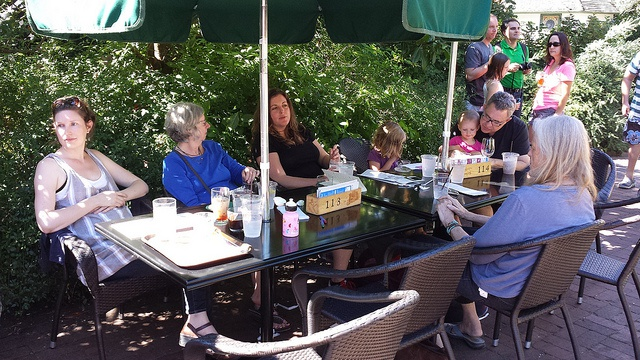Describe the objects in this image and their specific colors. I can see umbrella in darkgreen, black, white, teal, and gray tones, dining table in darkgreen, white, black, darkgray, and gray tones, people in darkgreen, blue, darkgray, and black tones, people in darkgreen, lavender, black, darkgray, and pink tones, and chair in darkgreen, black, gray, and navy tones in this image. 